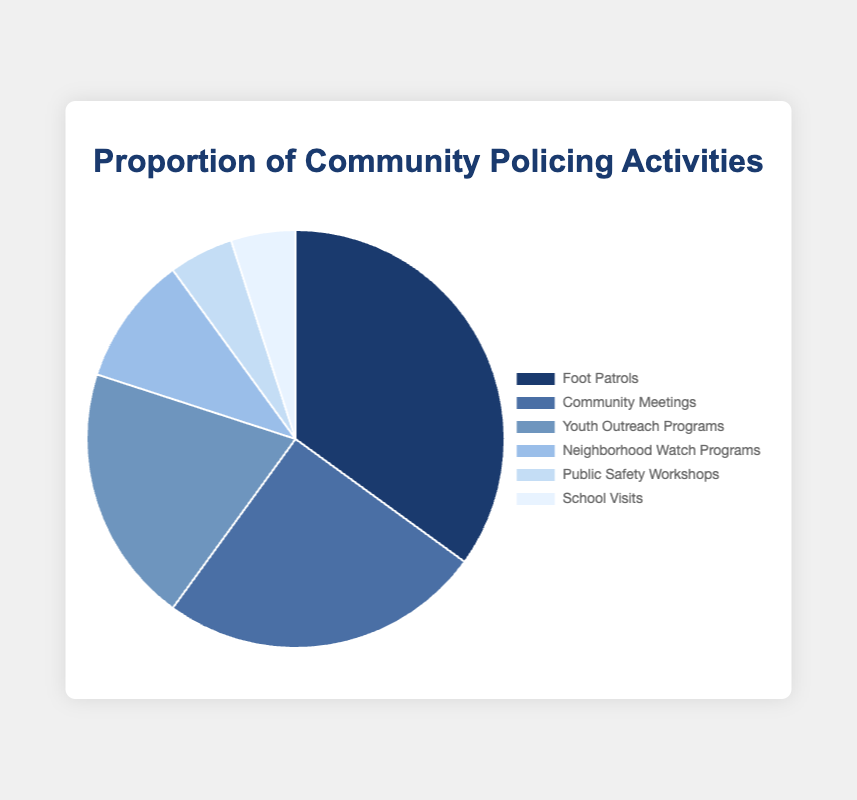Which community policing activity has the largest proportion? The pie chart shows that 'Foot Patrols' has the largest segment. By checking the proportions, 'Foot Patrols' has 35%, which is the highest among all activities.
Answer: Foot Patrols What is the combined proportion of 'Public Safety Workshops' and 'School Visits'? To find the combined proportion, add the proportions of 'Public Safety Workshops' (5%) and 'School Visits' (5%). So, 5% + 5% = 10%.
Answer: 10% Which activities have the same proportion? The pie chart shows that 'Public Safety Workshops' and 'School Visits' both have a proportion of 5%.
Answer: Public Safety Workshops and School Visits How much greater is the proportion of 'Foot Patrols' compared to 'Youth Outreach Programs'? The proportion of 'Foot Patrols' is 35% and 'Youth Outreach Programs' is 20%. Subtract the smaller proportion from the larger one: 35% - 20% = 15%.
Answer: 15% What is the second most common community policing activity? The second largest segment of the pie chart is 'Community Meetings', which has a proportion of 25%.
Answer: Community Meetings What's the combined proportion of 'Neighborhood Watch Programs' and 'Community Meetings'? Add the proportions of 'Neighborhood Watch Programs' (10%) and 'Community Meetings' (25%). So, 10% + 25% = 35%.
Answer: 35% Which activity represents one-third of 'Foot Patrols'? To find one-third of 'Foot Patrols' (35%), divide 35% by 3. This results in approximately 11.67%, and the closest activity is 'Neighborhood Watch Programs' with 10%, which is still the closest.
Answer: Neighborhood Watch Programs Among 'Foot Patrols', 'Community Meetings', and 'Youth Outreach Programs', which has the smallest proportion? The proportions are: 'Foot Patrols' (35%), 'Community Meetings' (25%), and 'Youth Outreach Programs' (20%). 'Youth Outreach Programs' has the smallest proportion among these.
Answer: Youth Outreach Programs What is the difference in proportion between the largest and smallest activities? The largest proportion is 'Foot Patrols' (35%) and the smallest are 'Public Safety Workshops' and 'School Visits' (5% each). Subtract the smallest from the largest: 35% - 5% = 30%.
Answer: 30% 